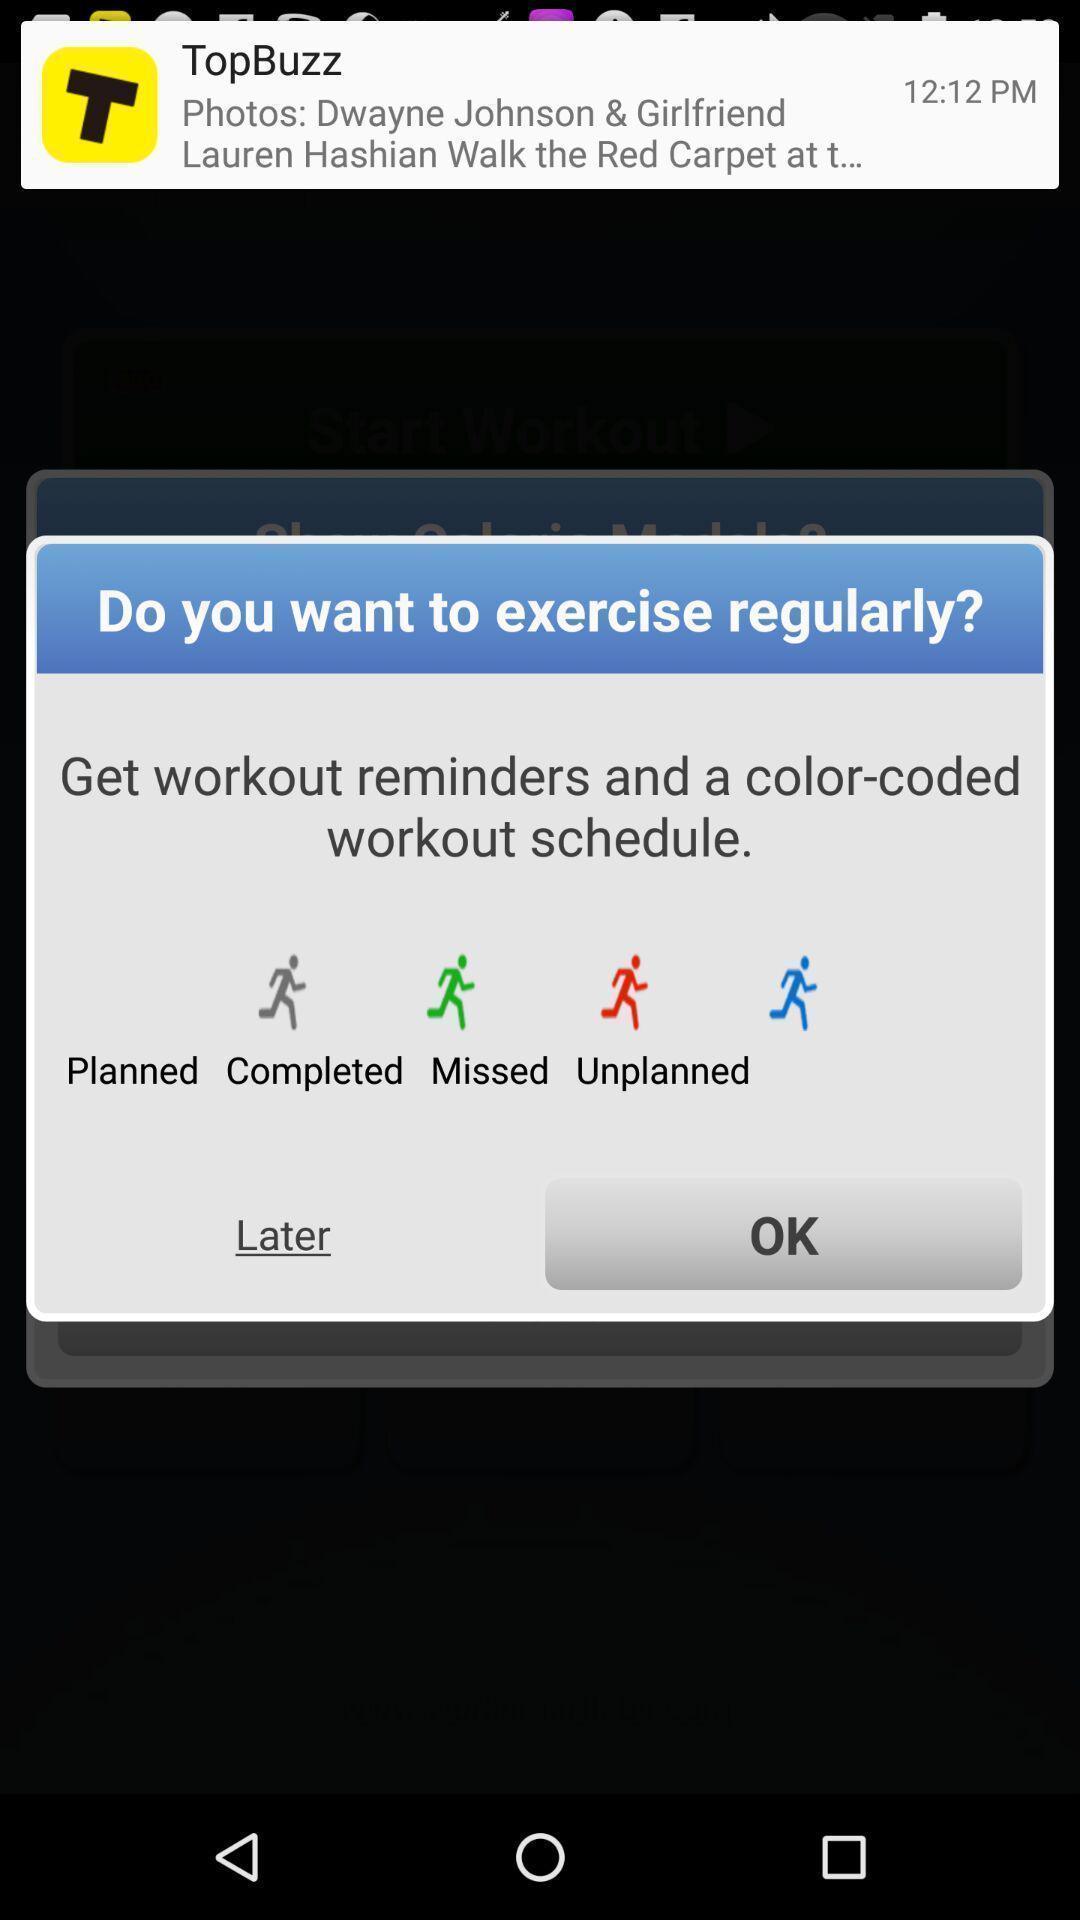Summarize the information in this screenshot. Pop-up showing reminder in a fitness app. 